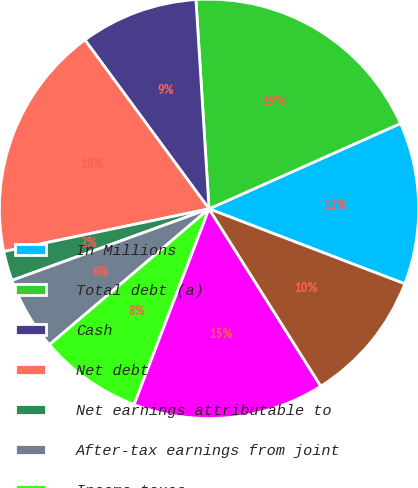Convert chart to OTSL. <chart><loc_0><loc_0><loc_500><loc_500><pie_chart><fcel>In Millions<fcel>Total debt (a)<fcel>Cash<fcel>Net debt<fcel>Net earnings attributable to<fcel>After-tax earnings from joint<fcel>Income taxes<fcel>Earnings before income taxes<fcel>Interest net<nl><fcel>12.5%<fcel>19.32%<fcel>9.09%<fcel>18.18%<fcel>2.28%<fcel>5.68%<fcel>7.96%<fcel>14.77%<fcel>10.23%<nl></chart> 